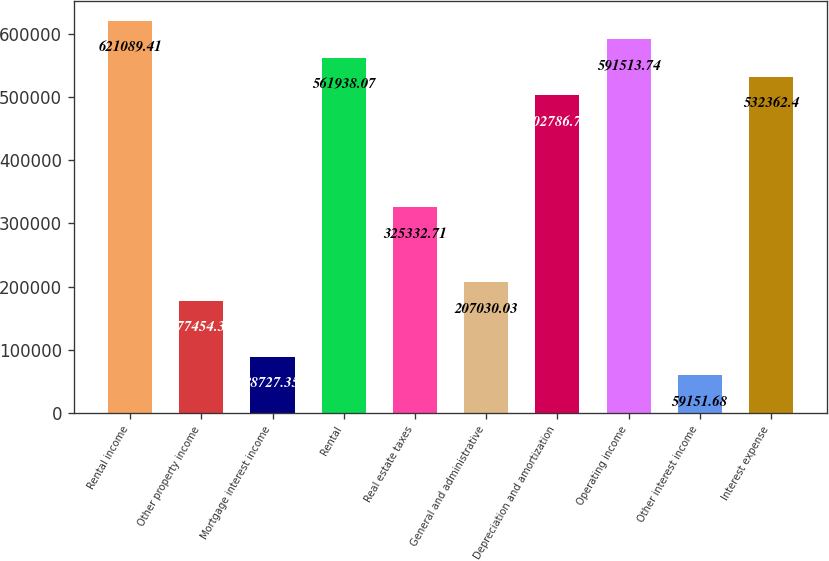Convert chart to OTSL. <chart><loc_0><loc_0><loc_500><loc_500><bar_chart><fcel>Rental income<fcel>Other property income<fcel>Mortgage interest income<fcel>Rental<fcel>Real estate taxes<fcel>General and administrative<fcel>Depreciation and amortization<fcel>Operating income<fcel>Other interest income<fcel>Interest expense<nl><fcel>621089<fcel>177454<fcel>88727.4<fcel>561938<fcel>325333<fcel>207030<fcel>502787<fcel>591514<fcel>59151.7<fcel>532362<nl></chart> 